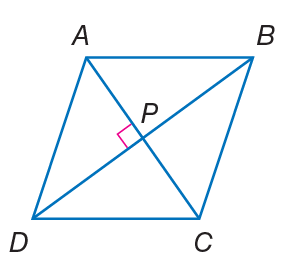Question: Quadrilateral A B C D is a rhombus. If m \angle A B C = 2 x - 7 and m \angle B C D = 2 x + 3, find m \angle D A B.
Choices:
A. 33
B. 50
C. 95
D. 120
Answer with the letter. Answer: C Question: Quadrilateral A B C D is a rhombus. If m \angle B C D = 54, find m \angle B A C.
Choices:
A. 13
B. 27
C. 50
D. 90
Answer with the letter. Answer: B Question: Quadrilateral A B C D is a rhombus. If A P = 3 x - 1 and P C = x + 9, find A C.
Choices:
A. 17
B. 28
C. 50
D. 76
Answer with the letter. Answer: B Question: Quadrilateral A B C D is a rhombus. If A B = 14, find B C.
Choices:
A. 14
B. 18
C. 20
D. 28
Answer with the letter. Answer: A Question: Quadrilateral A B C D is a rhombus. If m \angle D P C = 3 x - 15, find x.
Choices:
A. 14
B. 35
C. 56
D. 90
Answer with the letter. Answer: B 